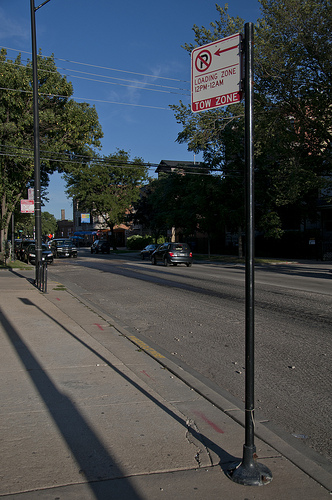What is the color of the car on the road? The car cruising down the road flaunts a sleek, dark blue exterior. 